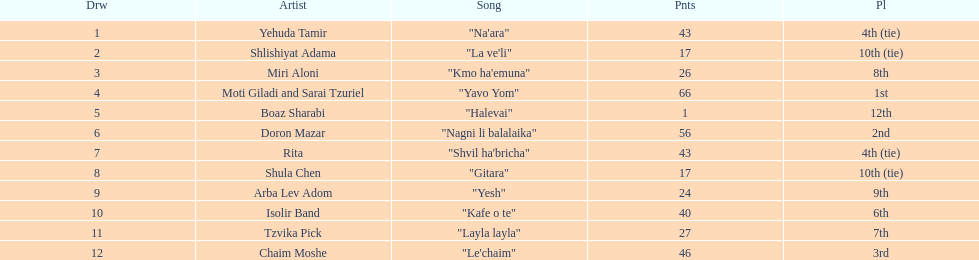What is the title of the track preceding the song "yesh"? "Gitara". 